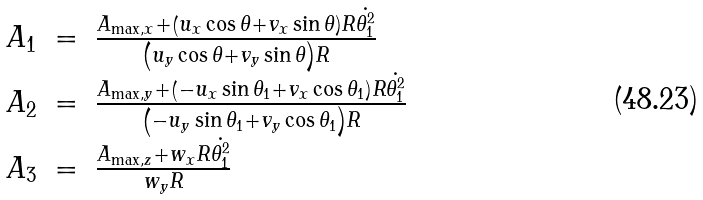Convert formula to latex. <formula><loc_0><loc_0><loc_500><loc_500>\begin{array} { r c l } A _ { 1 } & = & \frac { A _ { \max , x } + \left ( u _ { x } \cos \theta + v _ { x } \sin \theta \right ) R \dot { \theta _ { 1 } ^ { 2 } } } { \left ( u _ { y } \cos \theta + v _ { y } \sin \theta \right ) R } \\ A _ { 2 } & = & \frac { A _ { \max , y } + \left ( - u _ { x } \sin \theta _ { 1 } + v _ { x } \cos \theta _ { 1 } \right ) R \dot { \theta _ { 1 } ^ { 2 } } } { \left ( - u _ { y } \sin \theta _ { 1 } + v _ { y } \cos \theta _ { 1 } \right ) R } \\ A _ { 3 } & = & \frac { A _ { \max , z } + w _ { x } R \dot { \theta _ { 1 } ^ { 2 } } } { w _ { y } R } \end{array}</formula> 